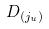<formula> <loc_0><loc_0><loc_500><loc_500>D _ { ( j _ { u } ) }</formula> 